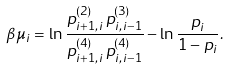Convert formula to latex. <formula><loc_0><loc_0><loc_500><loc_500>\beta \mu _ { i } = \ln \frac { p _ { i + 1 , i } ^ { ( 2 ) } \, p _ { i , i - 1 } ^ { ( 3 ) } } { p _ { i + 1 , i } ^ { ( 4 ) } \, p _ { i , i - 1 } ^ { ( 4 ) } } - \ln \frac { p _ { i } } { 1 - p _ { i } } .</formula> 